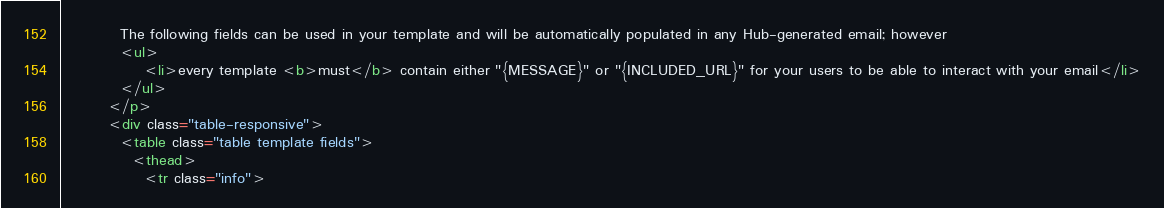<code> <loc_0><loc_0><loc_500><loc_500><_HTML_>          The following fields can be used in your template and will be automatically populated in any Hub-generated email; however
          <ul>
              <li>every template <b>must</b> contain either "{MESSAGE}" or "{INCLUDED_URL}" for your users to be able to interact with your email</li>
          </ul>
        </p>
        <div class="table-responsive">
          <table class="table template fields">
            <thead>
              <tr class="info"></code> 